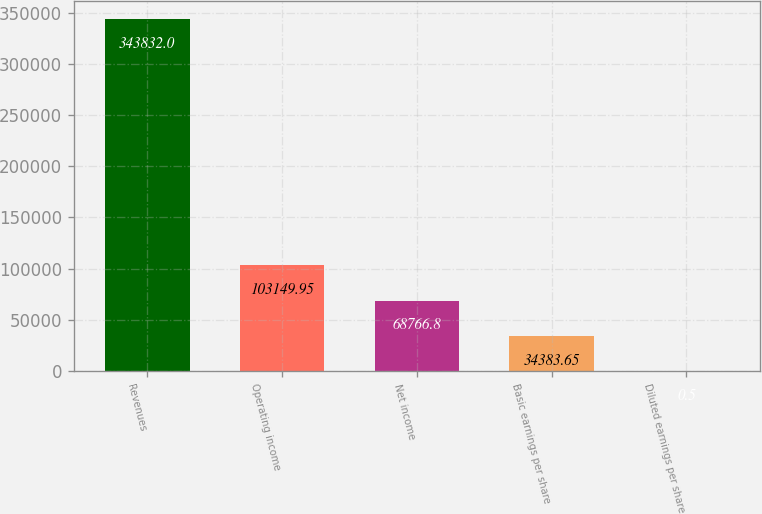Convert chart. <chart><loc_0><loc_0><loc_500><loc_500><bar_chart><fcel>Revenues<fcel>Operating income<fcel>Net income<fcel>Basic earnings per share<fcel>Diluted earnings per share<nl><fcel>343832<fcel>103150<fcel>68766.8<fcel>34383.7<fcel>0.5<nl></chart> 